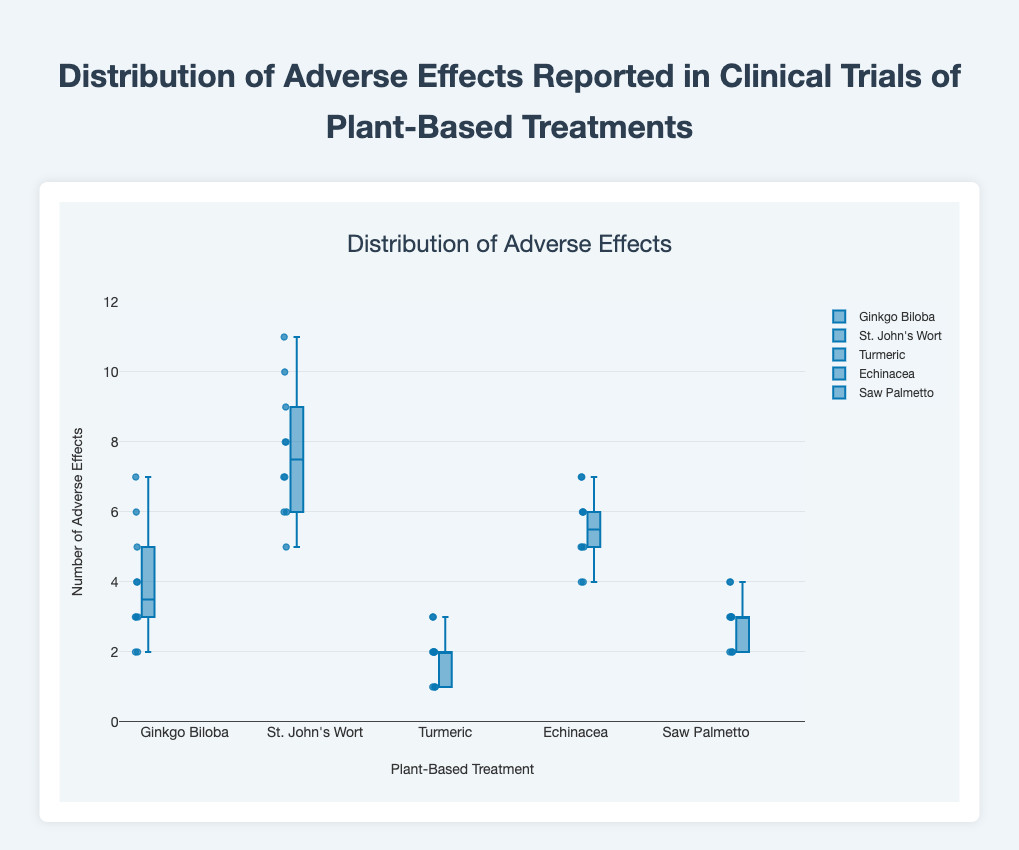What is the title of the box plot? The title is typically found at the top of the figure, visually indicating the main topic of the plot. In this case, the title is "Distribution of Adverse Effects Reported in Clinical Trials of Plant-Based Treatments."
Answer: Distribution of Adverse Effects Reported in Clinical Trials of Plant-Based Treatments What does the y-axis represent in the figure? The y-axis usually describes the type of measurement being visualized in the plot. Here, it represents "Number of Adverse Effects."
Answer: Number of Adverse Effects Which treatment shows the highest median number of adverse effects? To identify the highest median, check the central line within each box in the plot. "St. John's Wort" has the highest median number of adverse effects as its central line is higher than the others.
Answer: St. John's Wort Which treatment has the least variability in adverse effects? Variability can be visually assessed by the interquartile range (IQR) of the box. Turmeric has the smallest box, indicating the least variability.
Answer: Turmeric What is the median number of adverse effects for Echinacea? The median is marked by the line inside the box for Echinacea. Observing the plot, the line appears at 5.5 adverse effects.
Answer: 5.5 Which treatment has the highest reported adverse effect, and what is the value? To find the highest reported adverse effect, check the whiskers or outliers. "St. John's Wort" has the highest value at 11.
Answer: St. John's Wort, 11 Compare the median adverse effects between Ginkgo Biloba and Saw Palmetto. Which is higher? The median is the line within each box. Ginkgo Biloba's median is higher compared to Saw Palmetto's.
Answer: Ginkgo Biloba By how much does the median number of adverse effects for Turmeric differ from that of Echinacea? The median for Turmeric is 2, and for Echinacea, it is 5.5. The difference is 5.5 - 2 = 3.5.
Answer: 3.5 What does the box in a box plot represent? The box represents the interquartile range (IQR), which is the range between the first quartile (Q1) and the third quartile (Q3), encompassing the middle 50% of the data.
Answer: The interquartile range (IQR) 